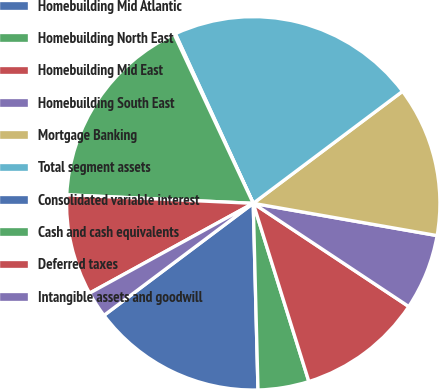Convert chart. <chart><loc_0><loc_0><loc_500><loc_500><pie_chart><fcel>Homebuilding Mid Atlantic<fcel>Homebuilding North East<fcel>Homebuilding Mid East<fcel>Homebuilding South East<fcel>Mortgage Banking<fcel>Total segment assets<fcel>Consolidated variable interest<fcel>Cash and cash equivalents<fcel>Deferred taxes<fcel>Intangible assets and goodwill<nl><fcel>15.16%<fcel>4.41%<fcel>10.86%<fcel>6.56%<fcel>13.01%<fcel>21.61%<fcel>0.11%<fcel>17.31%<fcel>8.71%<fcel>2.26%<nl></chart> 